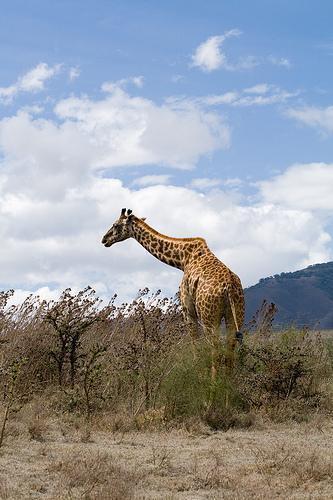How many giraffes are there?
Give a very brief answer. 1. 